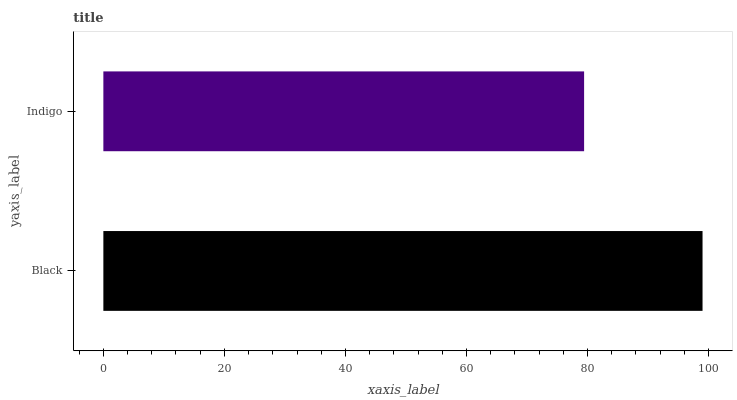Is Indigo the minimum?
Answer yes or no. Yes. Is Black the maximum?
Answer yes or no. Yes. Is Indigo the maximum?
Answer yes or no. No. Is Black greater than Indigo?
Answer yes or no. Yes. Is Indigo less than Black?
Answer yes or no. Yes. Is Indigo greater than Black?
Answer yes or no. No. Is Black less than Indigo?
Answer yes or no. No. Is Black the high median?
Answer yes or no. Yes. Is Indigo the low median?
Answer yes or no. Yes. Is Indigo the high median?
Answer yes or no. No. Is Black the low median?
Answer yes or no. No. 